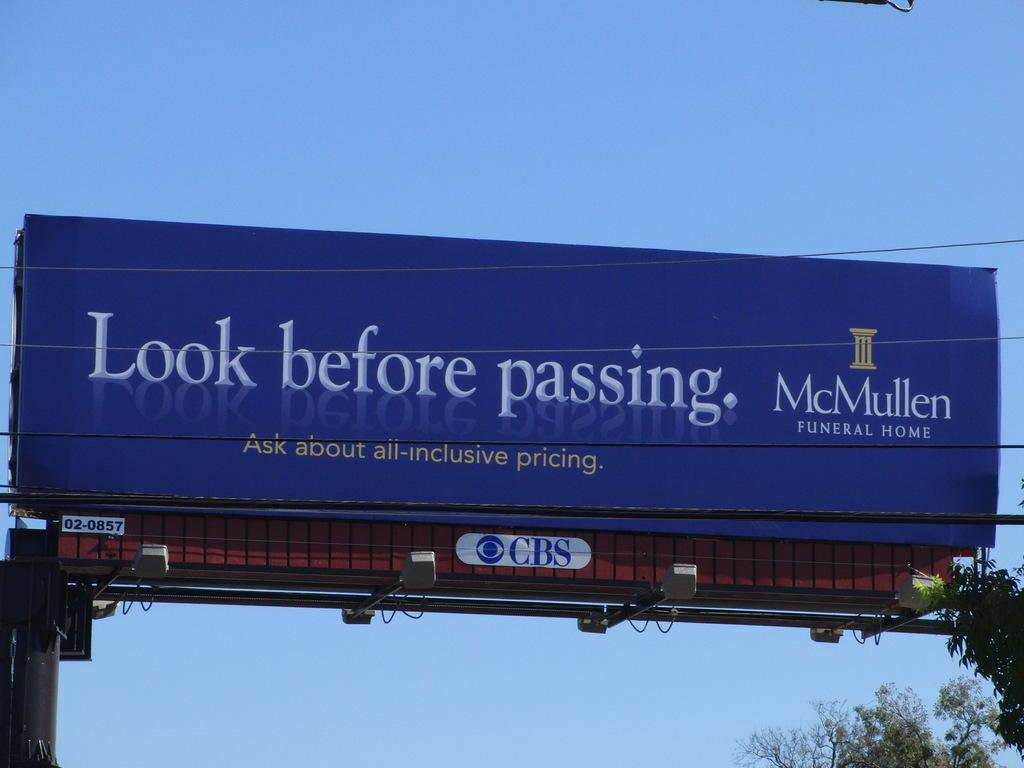Provide a one-sentence caption for the provided image. A roadside billboard displays an ad for a funeral home. 